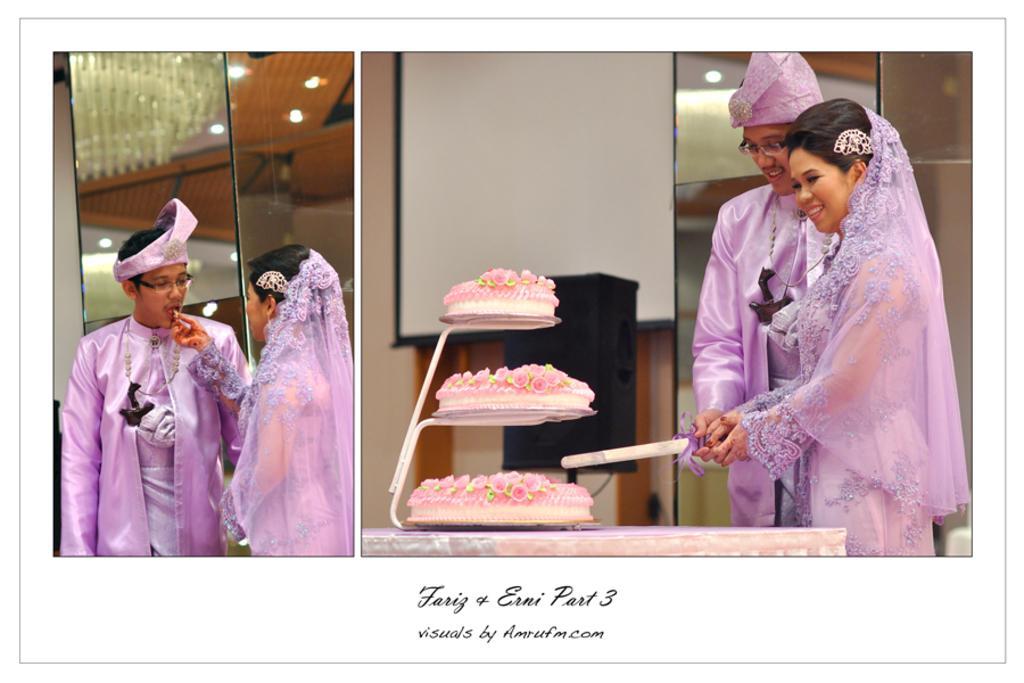Can you describe this image briefly? This is a collage image. Here I can see two pictures. In the right side picture I can see a woman and a man standing and cutting the cake which is placed on the table. In the background, I can see speaker and a board which is attached to the wall. In the the left side image the woman and man standing and looking at each other. At the back of them I can see a mirror. At the bottom of this image I can see some text. 